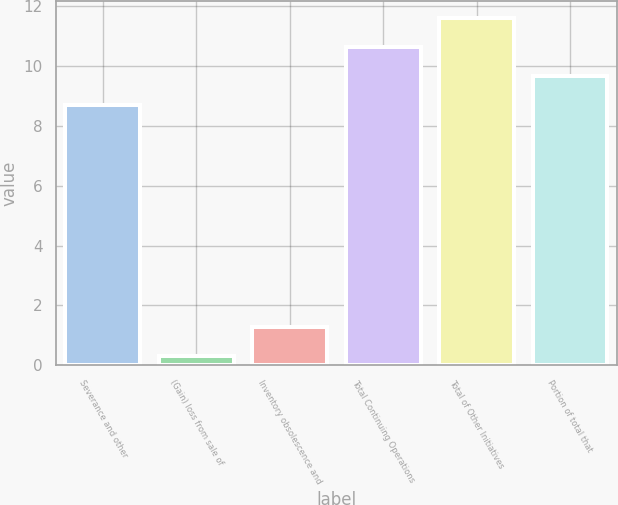Convert chart to OTSL. <chart><loc_0><loc_0><loc_500><loc_500><bar_chart><fcel>Severance and other<fcel>(Gain) loss from sale of<fcel>Inventory obsolescence and<fcel>Total Continuing Operations<fcel>Total of Other Initiatives<fcel>Portion of total that<nl><fcel>8.7<fcel>0.3<fcel>1.27<fcel>10.64<fcel>11.61<fcel>9.67<nl></chart> 